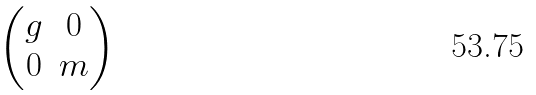Convert formula to latex. <formula><loc_0><loc_0><loc_500><loc_500>\begin{pmatrix} g & 0 \\ 0 & m \end{pmatrix}</formula> 